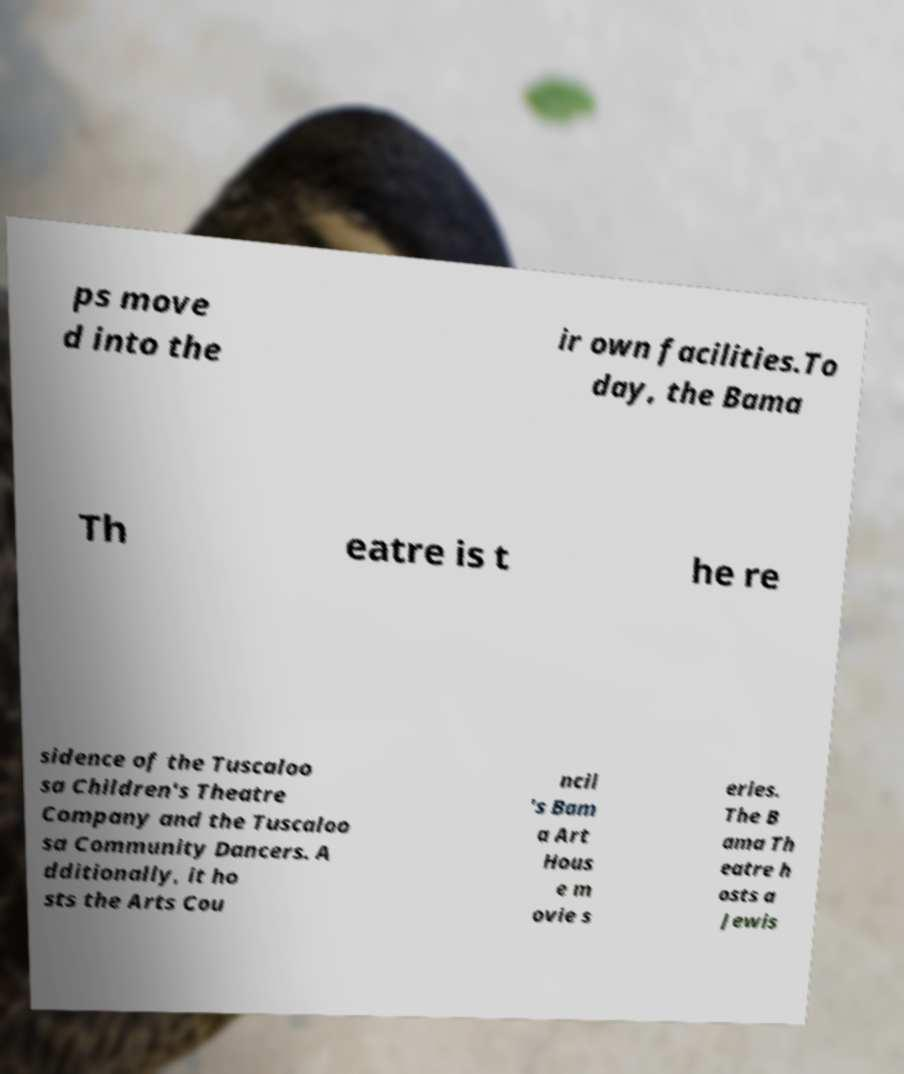Can you read and provide the text displayed in the image?This photo seems to have some interesting text. Can you extract and type it out for me? ps move d into the ir own facilities.To day, the Bama Th eatre is t he re sidence of the Tuscaloo sa Children's Theatre Company and the Tuscaloo sa Community Dancers. A dditionally, it ho sts the Arts Cou ncil 's Bam a Art Hous e m ovie s eries. The B ama Th eatre h osts a Jewis 